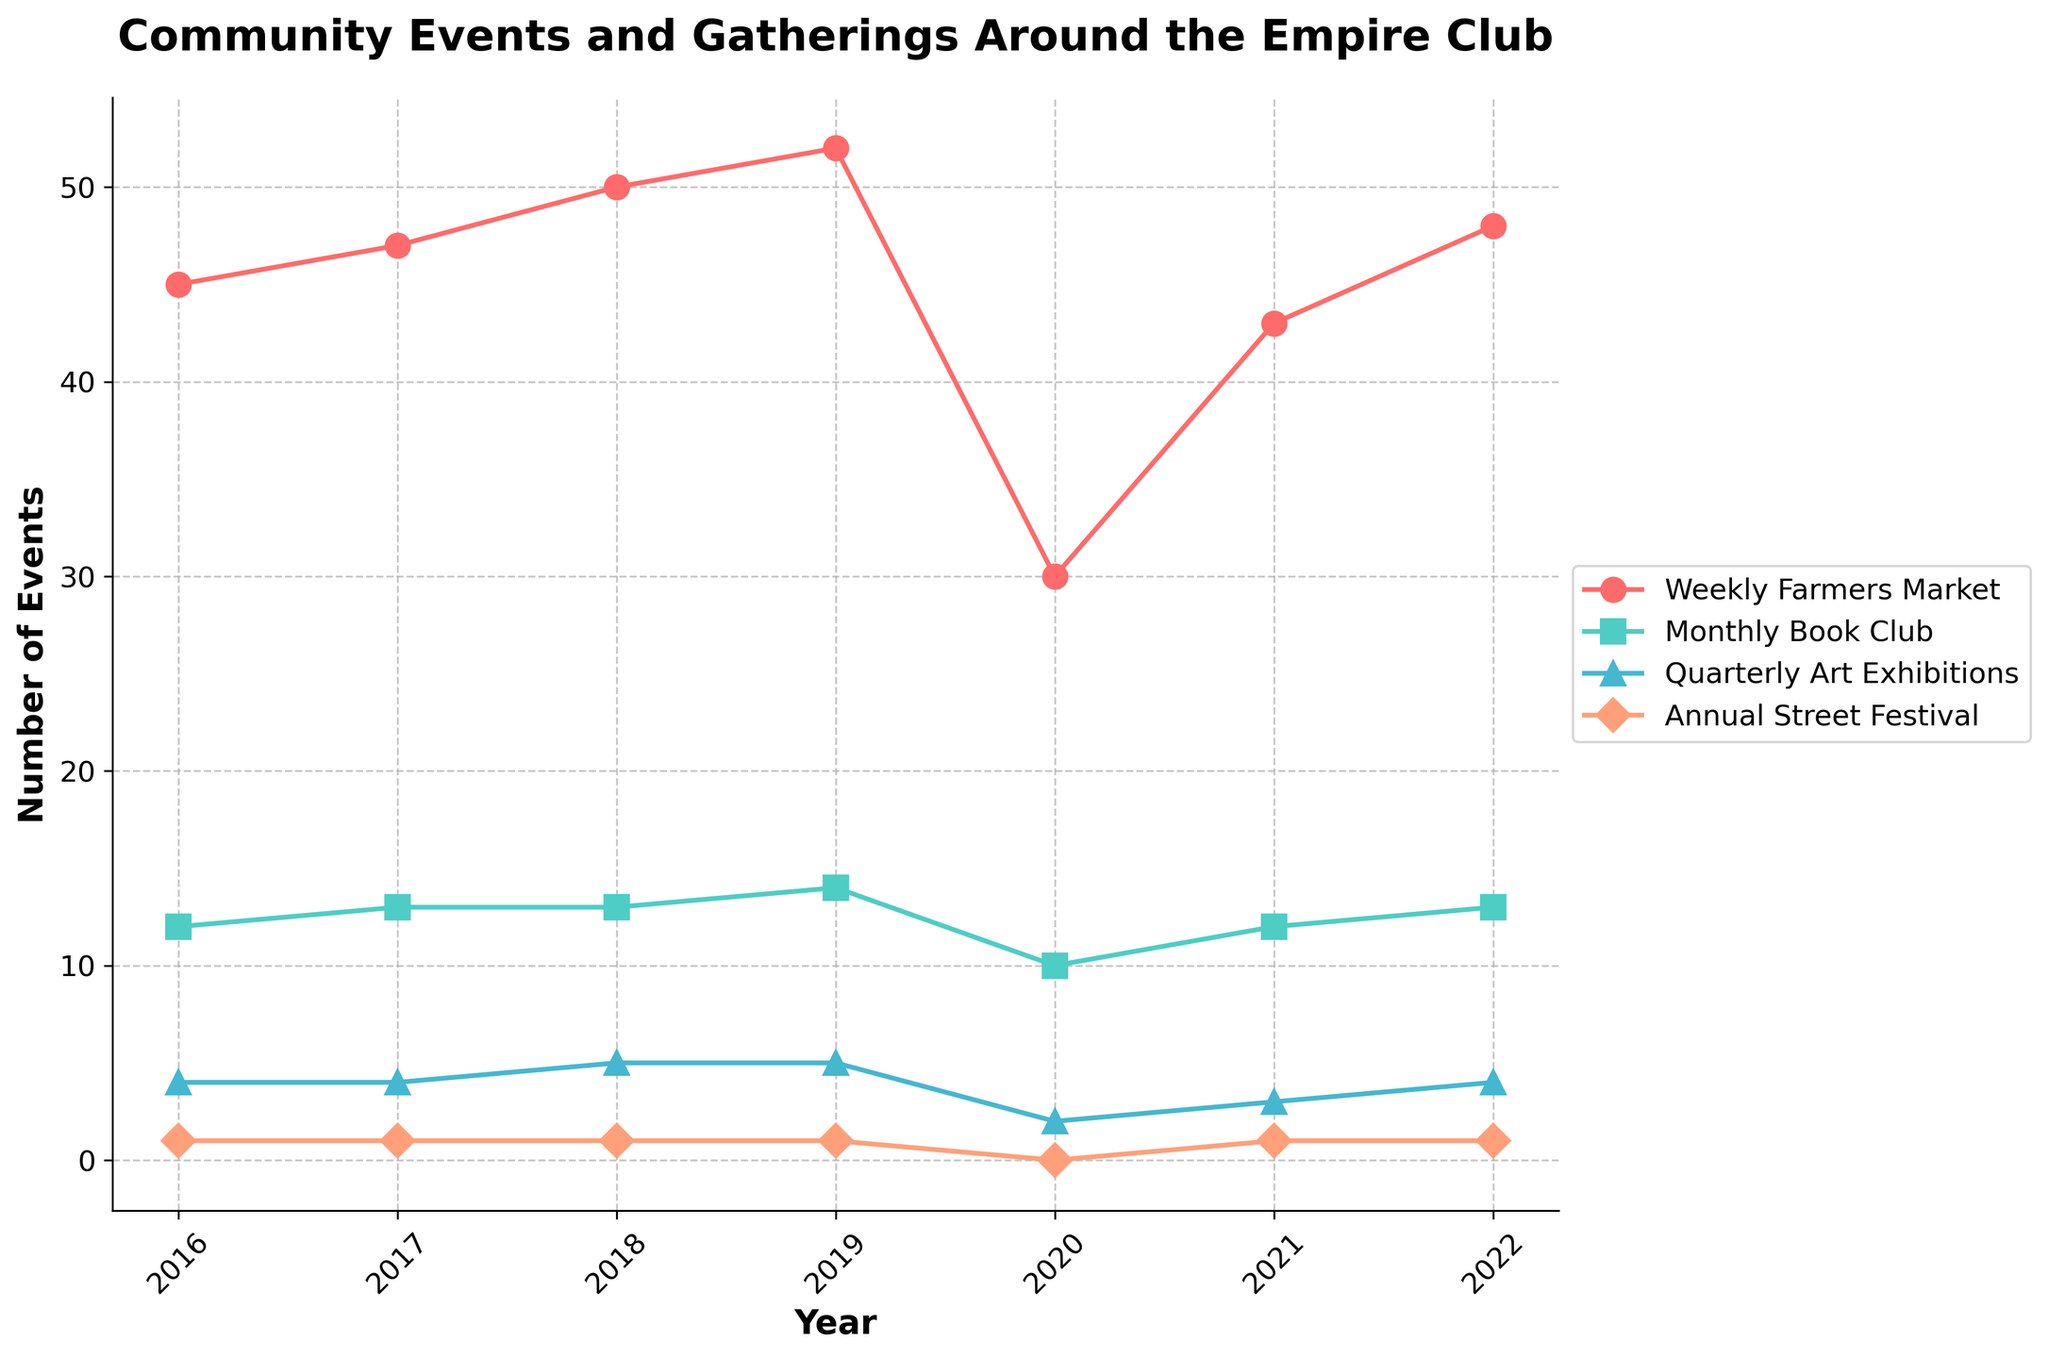**What's the title of the figure?** The title of the figure is displayed at the top and is a brief description of what the figure represents.
Answer: Community Events and Gatherings Around the Empire Club **How many events are represented in the figure?** There are four events represented in the figure, visible by the different colored lines and legend labels.
Answer: Four **Which event had the highest number of incidences in 2020?** By examining the data points for 2020, the "Weekly Farmers Market" had the highest number of incidences that year.
Answer: Weekly Farmers Market **Between which two consecutive years did the 'Weekly Farmers Market' see the greatest decrease in events?** By looking at the trend line, the largest drop occurs from 2019 to 2020.
Answer: 2019 to 2020 **Did any event not occur in any year, and if so, which one?** Checking the plot, the "Annual Street Festival" did not occur in 2020.
Answer: Annual Street Festival **What is the sum of the 'Monthly Book Club' events from 2016 to 2022?** Summing the data points for the 'Monthly Book Club' from the plot: 12+13+13+14+10+12+13 = 87
Answer: 87 **Which two events had the same number of incidences in 2019 and how many were there?** From the plot, the 'Quarterly Art Exhibitions' and 'Annual Street Festival' both had 5 and 1 incidences respectively in 2019.
Answer: Quarterly Art Exhibitions - 5, Annual Street Festival - 1 **How has the 'Quarterly Art Exhibitions' trend changed over the years?** Observing the trend line for 'Quarterly Art Exhibitions', it increases from 2016 to 2019, decreases in 2020, and slightly increases again by 2022.
Answer: Increase, decrease, increase **Which event had the most stable number of incidences through the years?** The trend line for 'Quarterly Art Exhibitions' remains relatively stable compared to the others.
Answer: Quarterly Art Exhibitions **What was the average number of 'Weekly Farmers Market' events per year from 2016 to 2022?** Find the average by summing the numbers (45+47+50+52+30+43+48) and dividing by 7. The sum is 315, so the average is 315/7 ≈ 45
Answer: 45 